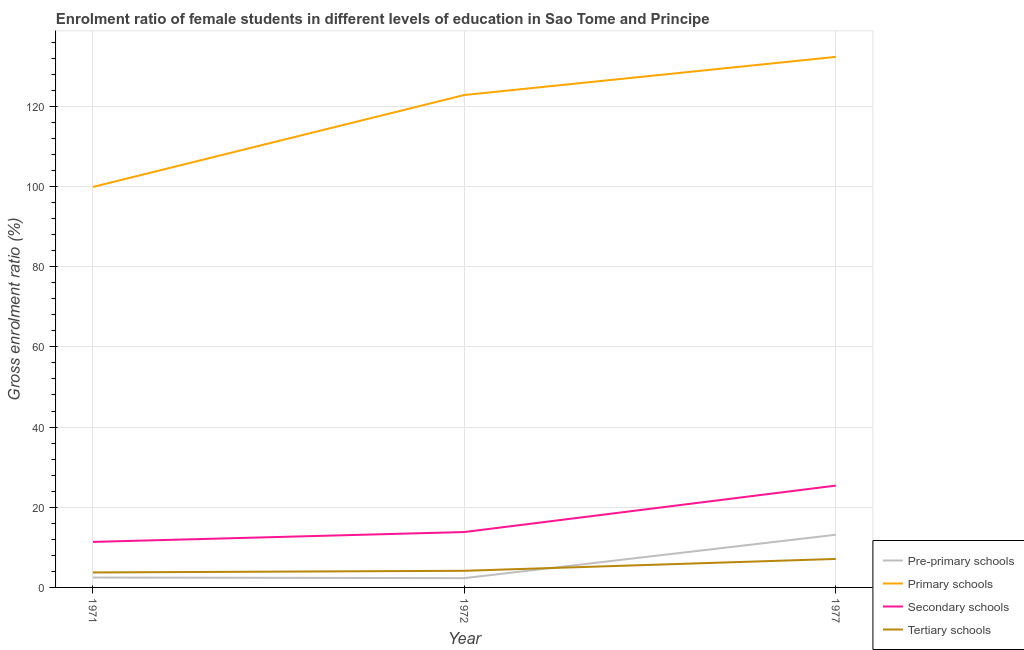Does the line corresponding to gross enrolment ratio(male) in tertiary schools intersect with the line corresponding to gross enrolment ratio(male) in secondary schools?
Offer a very short reply. No. What is the gross enrolment ratio(male) in tertiary schools in 1977?
Offer a very short reply. 7.11. Across all years, what is the maximum gross enrolment ratio(male) in secondary schools?
Provide a succinct answer. 25.4. Across all years, what is the minimum gross enrolment ratio(male) in primary schools?
Give a very brief answer. 99.9. In which year was the gross enrolment ratio(male) in secondary schools maximum?
Offer a very short reply. 1977. What is the total gross enrolment ratio(male) in primary schools in the graph?
Your response must be concise. 355.07. What is the difference between the gross enrolment ratio(male) in primary schools in 1971 and that in 1972?
Offer a terse response. -22.93. What is the difference between the gross enrolment ratio(male) in secondary schools in 1977 and the gross enrolment ratio(male) in pre-primary schools in 1972?
Your answer should be compact. 23.08. What is the average gross enrolment ratio(male) in tertiary schools per year?
Keep it short and to the point. 5. In the year 1971, what is the difference between the gross enrolment ratio(male) in pre-primary schools and gross enrolment ratio(male) in primary schools?
Provide a succinct answer. -97.43. What is the ratio of the gross enrolment ratio(male) in tertiary schools in 1971 to that in 1972?
Provide a succinct answer. 0.9. What is the difference between the highest and the second highest gross enrolment ratio(male) in pre-primary schools?
Provide a succinct answer. 10.67. What is the difference between the highest and the lowest gross enrolment ratio(male) in pre-primary schools?
Ensure brevity in your answer.  10.82. Is the sum of the gross enrolment ratio(male) in pre-primary schools in 1971 and 1972 greater than the maximum gross enrolment ratio(male) in tertiary schools across all years?
Your answer should be very brief. No. Is the gross enrolment ratio(male) in pre-primary schools strictly greater than the gross enrolment ratio(male) in secondary schools over the years?
Offer a terse response. No. Is the gross enrolment ratio(male) in secondary schools strictly less than the gross enrolment ratio(male) in tertiary schools over the years?
Provide a succinct answer. No. How many years are there in the graph?
Provide a succinct answer. 3. Are the values on the major ticks of Y-axis written in scientific E-notation?
Provide a short and direct response. No. Does the graph contain any zero values?
Give a very brief answer. No. Where does the legend appear in the graph?
Your answer should be compact. Bottom right. What is the title of the graph?
Provide a succinct answer. Enrolment ratio of female students in different levels of education in Sao Tome and Principe. Does "Insurance services" appear as one of the legend labels in the graph?
Offer a terse response. No. What is the label or title of the Y-axis?
Ensure brevity in your answer.  Gross enrolment ratio (%). What is the Gross enrolment ratio (%) of Pre-primary schools in 1971?
Make the answer very short. 2.47. What is the Gross enrolment ratio (%) of Primary schools in 1971?
Offer a very short reply. 99.9. What is the Gross enrolment ratio (%) of Secondary schools in 1971?
Provide a succinct answer. 11.35. What is the Gross enrolment ratio (%) of Tertiary schools in 1971?
Your response must be concise. 3.74. What is the Gross enrolment ratio (%) in Pre-primary schools in 1972?
Your answer should be very brief. 2.32. What is the Gross enrolment ratio (%) of Primary schools in 1972?
Your answer should be very brief. 122.83. What is the Gross enrolment ratio (%) in Secondary schools in 1972?
Provide a short and direct response. 13.82. What is the Gross enrolment ratio (%) in Tertiary schools in 1972?
Offer a very short reply. 4.15. What is the Gross enrolment ratio (%) of Pre-primary schools in 1977?
Offer a terse response. 13.14. What is the Gross enrolment ratio (%) of Primary schools in 1977?
Give a very brief answer. 132.34. What is the Gross enrolment ratio (%) of Secondary schools in 1977?
Ensure brevity in your answer.  25.4. What is the Gross enrolment ratio (%) in Tertiary schools in 1977?
Your answer should be compact. 7.11. Across all years, what is the maximum Gross enrolment ratio (%) in Pre-primary schools?
Your answer should be very brief. 13.14. Across all years, what is the maximum Gross enrolment ratio (%) in Primary schools?
Your response must be concise. 132.34. Across all years, what is the maximum Gross enrolment ratio (%) of Secondary schools?
Give a very brief answer. 25.4. Across all years, what is the maximum Gross enrolment ratio (%) in Tertiary schools?
Ensure brevity in your answer.  7.11. Across all years, what is the minimum Gross enrolment ratio (%) of Pre-primary schools?
Your answer should be very brief. 2.32. Across all years, what is the minimum Gross enrolment ratio (%) in Primary schools?
Provide a short and direct response. 99.9. Across all years, what is the minimum Gross enrolment ratio (%) of Secondary schools?
Offer a terse response. 11.35. Across all years, what is the minimum Gross enrolment ratio (%) in Tertiary schools?
Make the answer very short. 3.74. What is the total Gross enrolment ratio (%) in Pre-primary schools in the graph?
Keep it short and to the point. 17.92. What is the total Gross enrolment ratio (%) of Primary schools in the graph?
Give a very brief answer. 355.07. What is the total Gross enrolment ratio (%) in Secondary schools in the graph?
Provide a short and direct response. 50.57. What is the total Gross enrolment ratio (%) of Tertiary schools in the graph?
Ensure brevity in your answer.  14.99. What is the difference between the Gross enrolment ratio (%) in Pre-primary schools in 1971 and that in 1972?
Keep it short and to the point. 0.15. What is the difference between the Gross enrolment ratio (%) of Primary schools in 1971 and that in 1972?
Keep it short and to the point. -22.93. What is the difference between the Gross enrolment ratio (%) of Secondary schools in 1971 and that in 1972?
Your answer should be very brief. -2.47. What is the difference between the Gross enrolment ratio (%) in Tertiary schools in 1971 and that in 1972?
Provide a short and direct response. -0.41. What is the difference between the Gross enrolment ratio (%) in Pre-primary schools in 1971 and that in 1977?
Your response must be concise. -10.67. What is the difference between the Gross enrolment ratio (%) of Primary schools in 1971 and that in 1977?
Your answer should be very brief. -32.44. What is the difference between the Gross enrolment ratio (%) in Secondary schools in 1971 and that in 1977?
Your response must be concise. -14.04. What is the difference between the Gross enrolment ratio (%) of Tertiary schools in 1971 and that in 1977?
Provide a succinct answer. -3.37. What is the difference between the Gross enrolment ratio (%) of Pre-primary schools in 1972 and that in 1977?
Offer a very short reply. -10.82. What is the difference between the Gross enrolment ratio (%) of Primary schools in 1972 and that in 1977?
Provide a succinct answer. -9.51. What is the difference between the Gross enrolment ratio (%) of Secondary schools in 1972 and that in 1977?
Your answer should be compact. -11.58. What is the difference between the Gross enrolment ratio (%) of Tertiary schools in 1972 and that in 1977?
Provide a succinct answer. -2.96. What is the difference between the Gross enrolment ratio (%) in Pre-primary schools in 1971 and the Gross enrolment ratio (%) in Primary schools in 1972?
Give a very brief answer. -120.36. What is the difference between the Gross enrolment ratio (%) in Pre-primary schools in 1971 and the Gross enrolment ratio (%) in Secondary schools in 1972?
Keep it short and to the point. -11.35. What is the difference between the Gross enrolment ratio (%) of Pre-primary schools in 1971 and the Gross enrolment ratio (%) of Tertiary schools in 1972?
Keep it short and to the point. -1.68. What is the difference between the Gross enrolment ratio (%) of Primary schools in 1971 and the Gross enrolment ratio (%) of Secondary schools in 1972?
Ensure brevity in your answer.  86.08. What is the difference between the Gross enrolment ratio (%) of Primary schools in 1971 and the Gross enrolment ratio (%) of Tertiary schools in 1972?
Make the answer very short. 95.75. What is the difference between the Gross enrolment ratio (%) of Secondary schools in 1971 and the Gross enrolment ratio (%) of Tertiary schools in 1972?
Provide a short and direct response. 7.2. What is the difference between the Gross enrolment ratio (%) of Pre-primary schools in 1971 and the Gross enrolment ratio (%) of Primary schools in 1977?
Your answer should be very brief. -129.87. What is the difference between the Gross enrolment ratio (%) in Pre-primary schools in 1971 and the Gross enrolment ratio (%) in Secondary schools in 1977?
Offer a terse response. -22.93. What is the difference between the Gross enrolment ratio (%) of Pre-primary schools in 1971 and the Gross enrolment ratio (%) of Tertiary schools in 1977?
Your answer should be very brief. -4.64. What is the difference between the Gross enrolment ratio (%) of Primary schools in 1971 and the Gross enrolment ratio (%) of Secondary schools in 1977?
Provide a short and direct response. 74.5. What is the difference between the Gross enrolment ratio (%) in Primary schools in 1971 and the Gross enrolment ratio (%) in Tertiary schools in 1977?
Make the answer very short. 92.79. What is the difference between the Gross enrolment ratio (%) in Secondary schools in 1971 and the Gross enrolment ratio (%) in Tertiary schools in 1977?
Provide a succinct answer. 4.25. What is the difference between the Gross enrolment ratio (%) in Pre-primary schools in 1972 and the Gross enrolment ratio (%) in Primary schools in 1977?
Offer a terse response. -130.02. What is the difference between the Gross enrolment ratio (%) in Pre-primary schools in 1972 and the Gross enrolment ratio (%) in Secondary schools in 1977?
Give a very brief answer. -23.08. What is the difference between the Gross enrolment ratio (%) of Pre-primary schools in 1972 and the Gross enrolment ratio (%) of Tertiary schools in 1977?
Give a very brief answer. -4.79. What is the difference between the Gross enrolment ratio (%) in Primary schools in 1972 and the Gross enrolment ratio (%) in Secondary schools in 1977?
Make the answer very short. 97.43. What is the difference between the Gross enrolment ratio (%) in Primary schools in 1972 and the Gross enrolment ratio (%) in Tertiary schools in 1977?
Your response must be concise. 115.72. What is the difference between the Gross enrolment ratio (%) of Secondary schools in 1972 and the Gross enrolment ratio (%) of Tertiary schools in 1977?
Offer a terse response. 6.71. What is the average Gross enrolment ratio (%) of Pre-primary schools per year?
Your response must be concise. 5.97. What is the average Gross enrolment ratio (%) of Primary schools per year?
Give a very brief answer. 118.36. What is the average Gross enrolment ratio (%) in Secondary schools per year?
Offer a terse response. 16.86. What is the average Gross enrolment ratio (%) of Tertiary schools per year?
Your answer should be compact. 5. In the year 1971, what is the difference between the Gross enrolment ratio (%) in Pre-primary schools and Gross enrolment ratio (%) in Primary schools?
Offer a terse response. -97.43. In the year 1971, what is the difference between the Gross enrolment ratio (%) of Pre-primary schools and Gross enrolment ratio (%) of Secondary schools?
Offer a terse response. -8.88. In the year 1971, what is the difference between the Gross enrolment ratio (%) of Pre-primary schools and Gross enrolment ratio (%) of Tertiary schools?
Keep it short and to the point. -1.27. In the year 1971, what is the difference between the Gross enrolment ratio (%) in Primary schools and Gross enrolment ratio (%) in Secondary schools?
Ensure brevity in your answer.  88.55. In the year 1971, what is the difference between the Gross enrolment ratio (%) of Primary schools and Gross enrolment ratio (%) of Tertiary schools?
Give a very brief answer. 96.16. In the year 1971, what is the difference between the Gross enrolment ratio (%) in Secondary schools and Gross enrolment ratio (%) in Tertiary schools?
Offer a very short reply. 7.62. In the year 1972, what is the difference between the Gross enrolment ratio (%) of Pre-primary schools and Gross enrolment ratio (%) of Primary schools?
Offer a very short reply. -120.51. In the year 1972, what is the difference between the Gross enrolment ratio (%) in Pre-primary schools and Gross enrolment ratio (%) in Secondary schools?
Your response must be concise. -11.5. In the year 1972, what is the difference between the Gross enrolment ratio (%) in Pre-primary schools and Gross enrolment ratio (%) in Tertiary schools?
Your response must be concise. -1.83. In the year 1972, what is the difference between the Gross enrolment ratio (%) in Primary schools and Gross enrolment ratio (%) in Secondary schools?
Ensure brevity in your answer.  109.01. In the year 1972, what is the difference between the Gross enrolment ratio (%) in Primary schools and Gross enrolment ratio (%) in Tertiary schools?
Offer a terse response. 118.68. In the year 1972, what is the difference between the Gross enrolment ratio (%) in Secondary schools and Gross enrolment ratio (%) in Tertiary schools?
Provide a succinct answer. 9.67. In the year 1977, what is the difference between the Gross enrolment ratio (%) in Pre-primary schools and Gross enrolment ratio (%) in Primary schools?
Your answer should be very brief. -119.2. In the year 1977, what is the difference between the Gross enrolment ratio (%) in Pre-primary schools and Gross enrolment ratio (%) in Secondary schools?
Your response must be concise. -12.26. In the year 1977, what is the difference between the Gross enrolment ratio (%) of Pre-primary schools and Gross enrolment ratio (%) of Tertiary schools?
Make the answer very short. 6.03. In the year 1977, what is the difference between the Gross enrolment ratio (%) in Primary schools and Gross enrolment ratio (%) in Secondary schools?
Offer a terse response. 106.94. In the year 1977, what is the difference between the Gross enrolment ratio (%) of Primary schools and Gross enrolment ratio (%) of Tertiary schools?
Provide a short and direct response. 125.23. In the year 1977, what is the difference between the Gross enrolment ratio (%) of Secondary schools and Gross enrolment ratio (%) of Tertiary schools?
Provide a succinct answer. 18.29. What is the ratio of the Gross enrolment ratio (%) of Pre-primary schools in 1971 to that in 1972?
Your answer should be compact. 1.07. What is the ratio of the Gross enrolment ratio (%) of Primary schools in 1971 to that in 1972?
Your answer should be compact. 0.81. What is the ratio of the Gross enrolment ratio (%) in Secondary schools in 1971 to that in 1972?
Your response must be concise. 0.82. What is the ratio of the Gross enrolment ratio (%) of Tertiary schools in 1971 to that in 1972?
Offer a very short reply. 0.9. What is the ratio of the Gross enrolment ratio (%) of Pre-primary schools in 1971 to that in 1977?
Offer a very short reply. 0.19. What is the ratio of the Gross enrolment ratio (%) of Primary schools in 1971 to that in 1977?
Provide a succinct answer. 0.75. What is the ratio of the Gross enrolment ratio (%) in Secondary schools in 1971 to that in 1977?
Your response must be concise. 0.45. What is the ratio of the Gross enrolment ratio (%) of Tertiary schools in 1971 to that in 1977?
Provide a short and direct response. 0.53. What is the ratio of the Gross enrolment ratio (%) in Pre-primary schools in 1972 to that in 1977?
Give a very brief answer. 0.18. What is the ratio of the Gross enrolment ratio (%) in Primary schools in 1972 to that in 1977?
Make the answer very short. 0.93. What is the ratio of the Gross enrolment ratio (%) of Secondary schools in 1972 to that in 1977?
Offer a terse response. 0.54. What is the ratio of the Gross enrolment ratio (%) of Tertiary schools in 1972 to that in 1977?
Provide a short and direct response. 0.58. What is the difference between the highest and the second highest Gross enrolment ratio (%) in Pre-primary schools?
Your answer should be very brief. 10.67. What is the difference between the highest and the second highest Gross enrolment ratio (%) in Primary schools?
Make the answer very short. 9.51. What is the difference between the highest and the second highest Gross enrolment ratio (%) of Secondary schools?
Your answer should be compact. 11.58. What is the difference between the highest and the second highest Gross enrolment ratio (%) of Tertiary schools?
Offer a terse response. 2.96. What is the difference between the highest and the lowest Gross enrolment ratio (%) of Pre-primary schools?
Offer a very short reply. 10.82. What is the difference between the highest and the lowest Gross enrolment ratio (%) of Primary schools?
Provide a short and direct response. 32.44. What is the difference between the highest and the lowest Gross enrolment ratio (%) of Secondary schools?
Give a very brief answer. 14.04. What is the difference between the highest and the lowest Gross enrolment ratio (%) of Tertiary schools?
Ensure brevity in your answer.  3.37. 